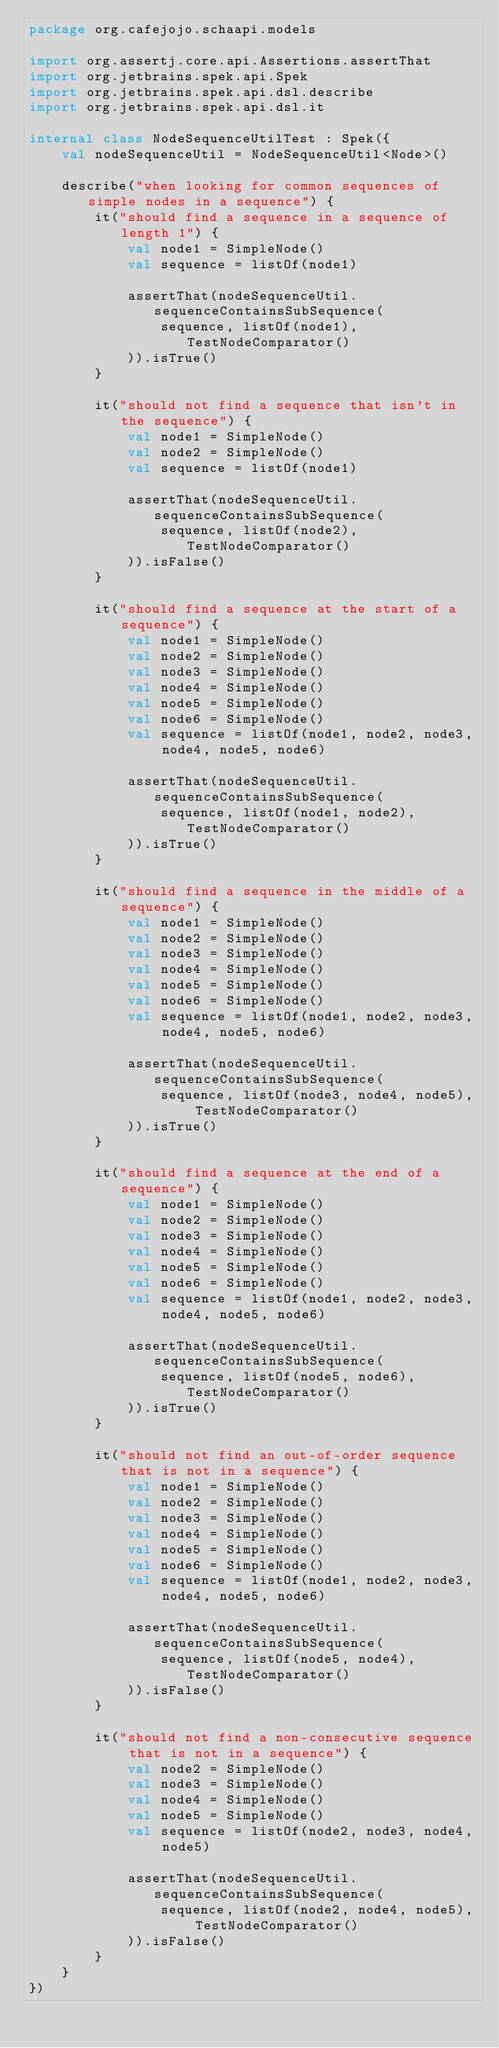Convert code to text. <code><loc_0><loc_0><loc_500><loc_500><_Kotlin_>package org.cafejojo.schaapi.models

import org.assertj.core.api.Assertions.assertThat
import org.jetbrains.spek.api.Spek
import org.jetbrains.spek.api.dsl.describe
import org.jetbrains.spek.api.dsl.it

internal class NodeSequenceUtilTest : Spek({
    val nodeSequenceUtil = NodeSequenceUtil<Node>()

    describe("when looking for common sequences of simple nodes in a sequence") {
        it("should find a sequence in a sequence of length 1") {
            val node1 = SimpleNode()
            val sequence = listOf(node1)

            assertThat(nodeSequenceUtil.sequenceContainsSubSequence(
                sequence, listOf(node1), TestNodeComparator()
            )).isTrue()
        }

        it("should not find a sequence that isn't in the sequence") {
            val node1 = SimpleNode()
            val node2 = SimpleNode()
            val sequence = listOf(node1)

            assertThat(nodeSequenceUtil.sequenceContainsSubSequence(
                sequence, listOf(node2), TestNodeComparator()
            )).isFalse()
        }

        it("should find a sequence at the start of a sequence") {
            val node1 = SimpleNode()
            val node2 = SimpleNode()
            val node3 = SimpleNode()
            val node4 = SimpleNode()
            val node5 = SimpleNode()
            val node6 = SimpleNode()
            val sequence = listOf(node1, node2, node3, node4, node5, node6)

            assertThat(nodeSequenceUtil.sequenceContainsSubSequence(
                sequence, listOf(node1, node2), TestNodeComparator()
            )).isTrue()
        }

        it("should find a sequence in the middle of a sequence") {
            val node1 = SimpleNode()
            val node2 = SimpleNode()
            val node3 = SimpleNode()
            val node4 = SimpleNode()
            val node5 = SimpleNode()
            val node6 = SimpleNode()
            val sequence = listOf(node1, node2, node3, node4, node5, node6)

            assertThat(nodeSequenceUtil.sequenceContainsSubSequence(
                sequence, listOf(node3, node4, node5), TestNodeComparator()
            )).isTrue()
        }

        it("should find a sequence at the end of a sequence") {
            val node1 = SimpleNode()
            val node2 = SimpleNode()
            val node3 = SimpleNode()
            val node4 = SimpleNode()
            val node5 = SimpleNode()
            val node6 = SimpleNode()
            val sequence = listOf(node1, node2, node3, node4, node5, node6)

            assertThat(nodeSequenceUtil.sequenceContainsSubSequence(
                sequence, listOf(node5, node6), TestNodeComparator()
            )).isTrue()
        }

        it("should not find an out-of-order sequence that is not in a sequence") {
            val node1 = SimpleNode()
            val node2 = SimpleNode()
            val node3 = SimpleNode()
            val node4 = SimpleNode()
            val node5 = SimpleNode()
            val node6 = SimpleNode()
            val sequence = listOf(node1, node2, node3, node4, node5, node6)

            assertThat(nodeSequenceUtil.sequenceContainsSubSequence(
                sequence, listOf(node5, node4), TestNodeComparator()
            )).isFalse()
        }

        it("should not find a non-consecutive sequence that is not in a sequence") {
            val node2 = SimpleNode()
            val node3 = SimpleNode()
            val node4 = SimpleNode()
            val node5 = SimpleNode()
            val sequence = listOf(node2, node3, node4, node5)

            assertThat(nodeSequenceUtil.sequenceContainsSubSequence(
                sequence, listOf(node2, node4, node5), TestNodeComparator()
            )).isFalse()
        }
    }
})
</code> 